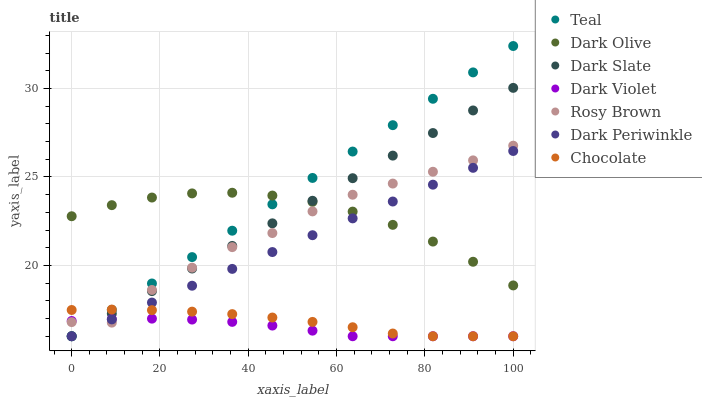Does Dark Violet have the minimum area under the curve?
Answer yes or no. Yes. Does Teal have the maximum area under the curve?
Answer yes or no. Yes. Does Rosy Brown have the minimum area under the curve?
Answer yes or no. No. Does Rosy Brown have the maximum area under the curve?
Answer yes or no. No. Is Dark Slate the smoothest?
Answer yes or no. Yes. Is Rosy Brown the roughest?
Answer yes or no. Yes. Is Dark Violet the smoothest?
Answer yes or no. No. Is Dark Violet the roughest?
Answer yes or no. No. Does Dark Violet have the lowest value?
Answer yes or no. Yes. Does Rosy Brown have the lowest value?
Answer yes or no. No. Does Teal have the highest value?
Answer yes or no. Yes. Does Rosy Brown have the highest value?
Answer yes or no. No. Is Dark Violet less than Dark Olive?
Answer yes or no. Yes. Is Dark Olive greater than Chocolate?
Answer yes or no. Yes. Does Chocolate intersect Teal?
Answer yes or no. Yes. Is Chocolate less than Teal?
Answer yes or no. No. Is Chocolate greater than Teal?
Answer yes or no. No. Does Dark Violet intersect Dark Olive?
Answer yes or no. No. 